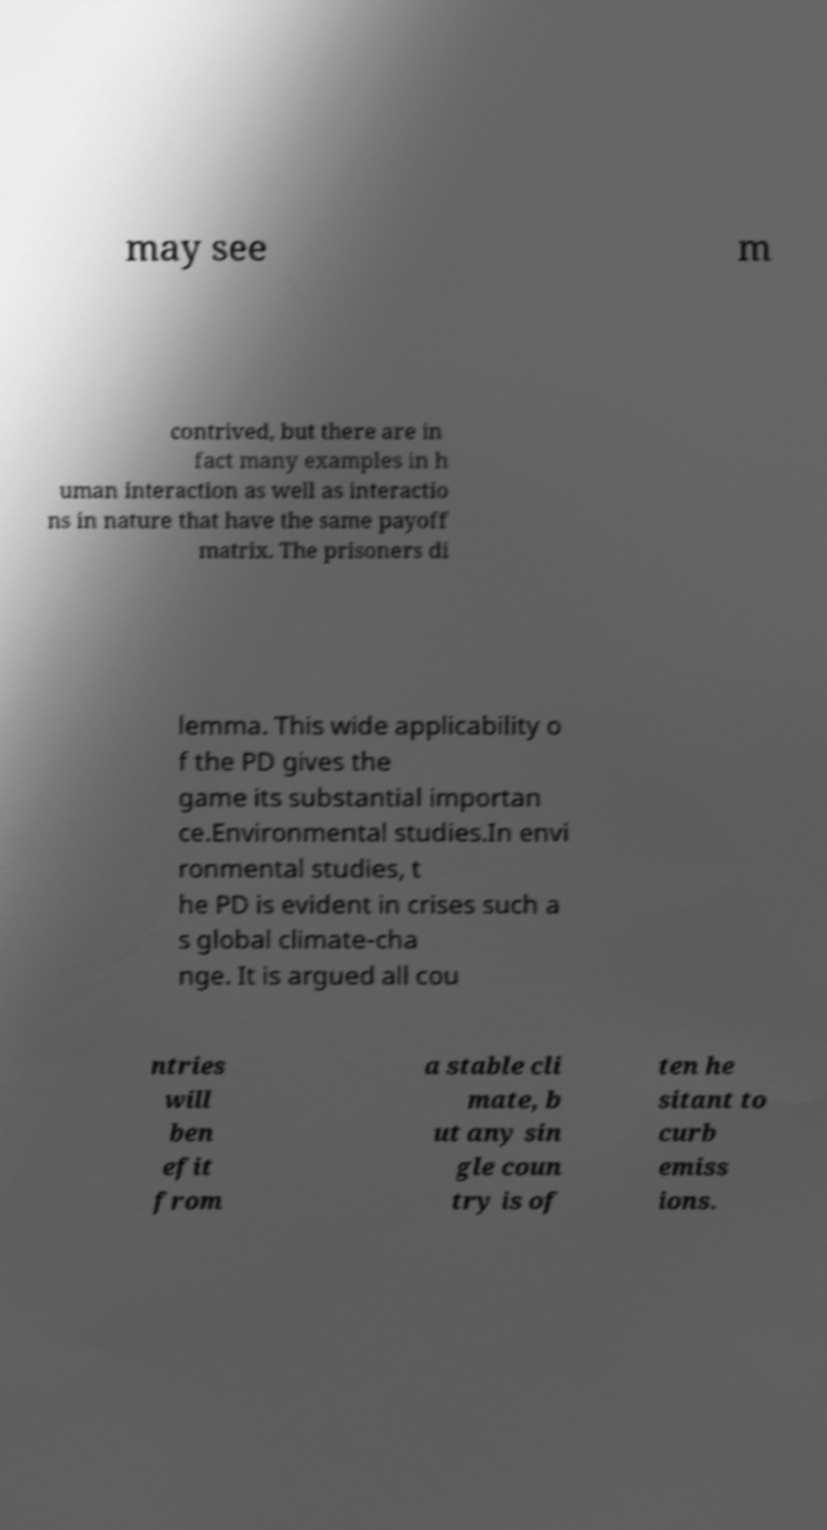I need the written content from this picture converted into text. Can you do that? may see m contrived, but there are in fact many examples in h uman interaction as well as interactio ns in nature that have the same payoff matrix. The prisoners di lemma. This wide applicability o f the PD gives the game its substantial importan ce.Environmental studies.In envi ronmental studies, t he PD is evident in crises such a s global climate-cha nge. It is argued all cou ntries will ben efit from a stable cli mate, b ut any sin gle coun try is of ten he sitant to curb emiss ions. 